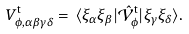Convert formula to latex. <formula><loc_0><loc_0><loc_500><loc_500>V ^ { \text {t} } _ { \phi , \alpha \beta \gamma \delta } = \, \langle { \xi } _ { \alpha } { \xi } _ { \beta } | \hat { \mathcal { V } } _ { \phi } ^ { \text {t} } | { \xi } _ { \gamma } \xi _ { \delta } \rangle .</formula> 